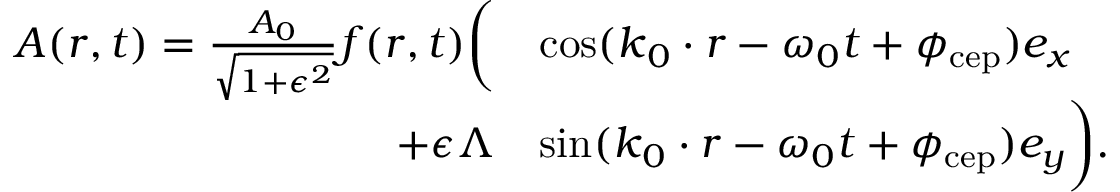Convert formula to latex. <formula><loc_0><loc_0><loc_500><loc_500>\begin{array} { r l } { A ( r , t ) = \frac { A _ { 0 } } { \sqrt { 1 + \epsilon ^ { 2 } } } f ( r , t ) \left ( } & { \cos ( k _ { 0 } \cdot r - \omega _ { 0 } t + \phi _ { c e p } ) e _ { x } } \\ { + \epsilon \Lambda } & { \sin ( k _ { 0 } \cdot r - \omega _ { 0 } t + \phi _ { c e p } ) e _ { y } \right ) . } \end{array}</formula> 